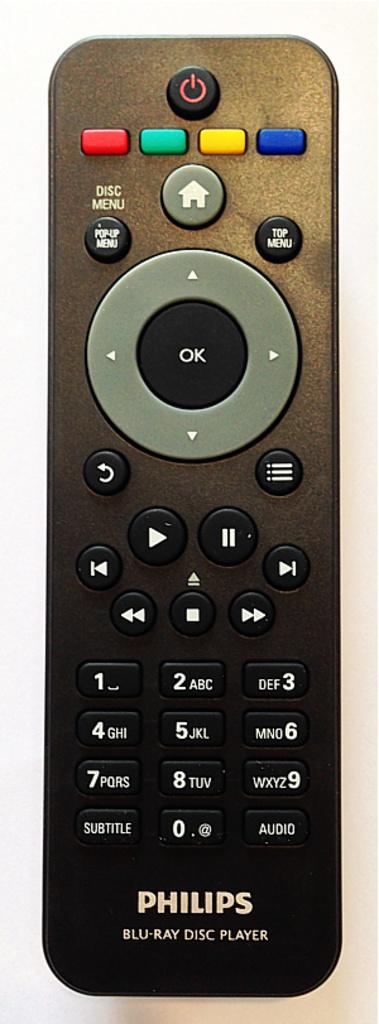Provide a one-sentence caption for the provided image. A Philips brand remote has colorful buttons at the top. 